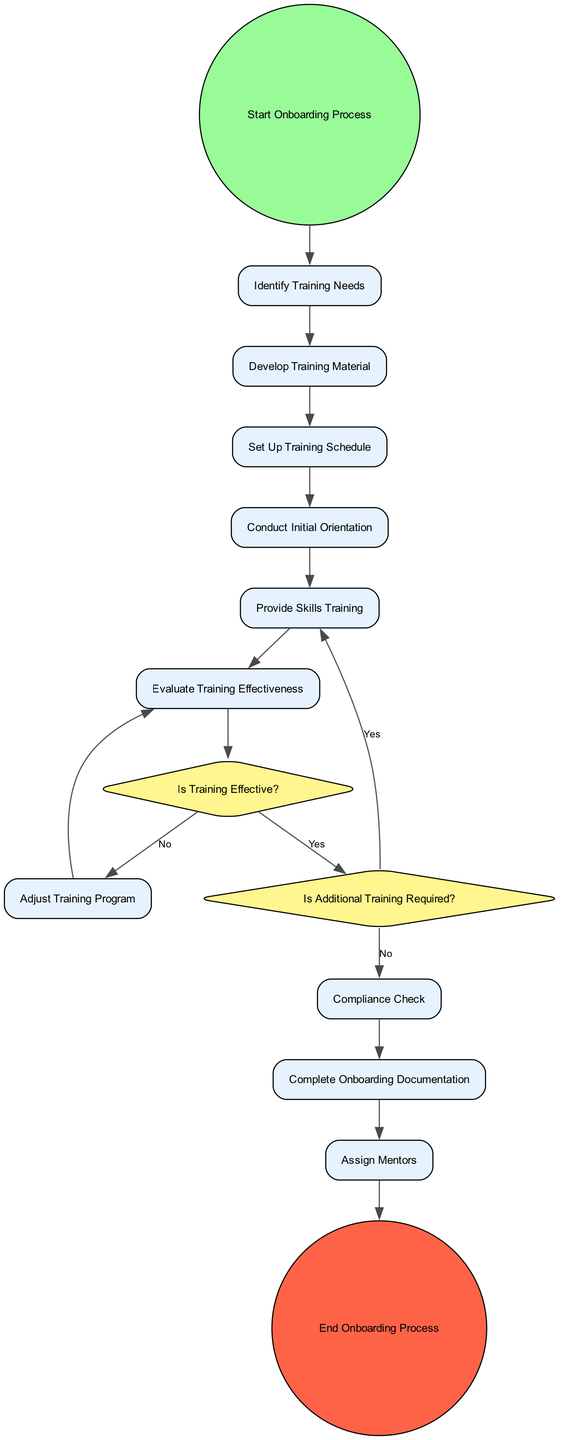What is the first activity in the onboarding process? The first activity listed in the diagram is "Identify Training Needs," which directly follows the start event.
Answer: Identify Training Needs How many activities are there in total? Counting the activities listed in the diagram, there are ten activities present.
Answer: Ten What occurs after "Conduct Initial Orientation"? Following "Conduct Initial Orientation," the next activity is "Provide Skills Training." This can be traced through the flow of edges connecting these two activities.
Answer: Provide Skills Training What is the outcome if the training is found to be effective? If the training is determined to be effective, the flow advances to the decision point "Is Additional Training Required?" leading back to job-specific skills training if no further training is required.
Answer: Yes What is the last step in the process? The last step, represented by the end event, is "End Onboarding Process," which concludes the process after all prior activities have been completed.
Answer: End Onboarding Process What is the role of the "Assign Mentors" activity? The "Assign Mentors" activity ensures that new employees are paired with experienced staff for guidance and support, which is directly after conducting necessary compliance checks if there is no additional training needed.
Answer: Pair new employees with experienced staff How often is the "Evaluate Training Effectiveness" activity performed? This activity occurs once in the linear sequence following the skills training and before the decision point about the training's effectiveness, indicating it is assessed after every training session.
Answer: Once What happens if additional training is required? If additional training is required, the flow indicates that it loops back to "Provide Skills Training," assuring that necessary skills are reinforced until the objectives are met.
Answer: Provide Skills Training What is the purpose of the "Compliance Check"? The "Compliance Check" activity ensures that all training meets company and regulatory standards and follows the evaluation of training effectiveness, making it a critical step for legal conformity.
Answer: Ensure training meets company and regulatory standards 